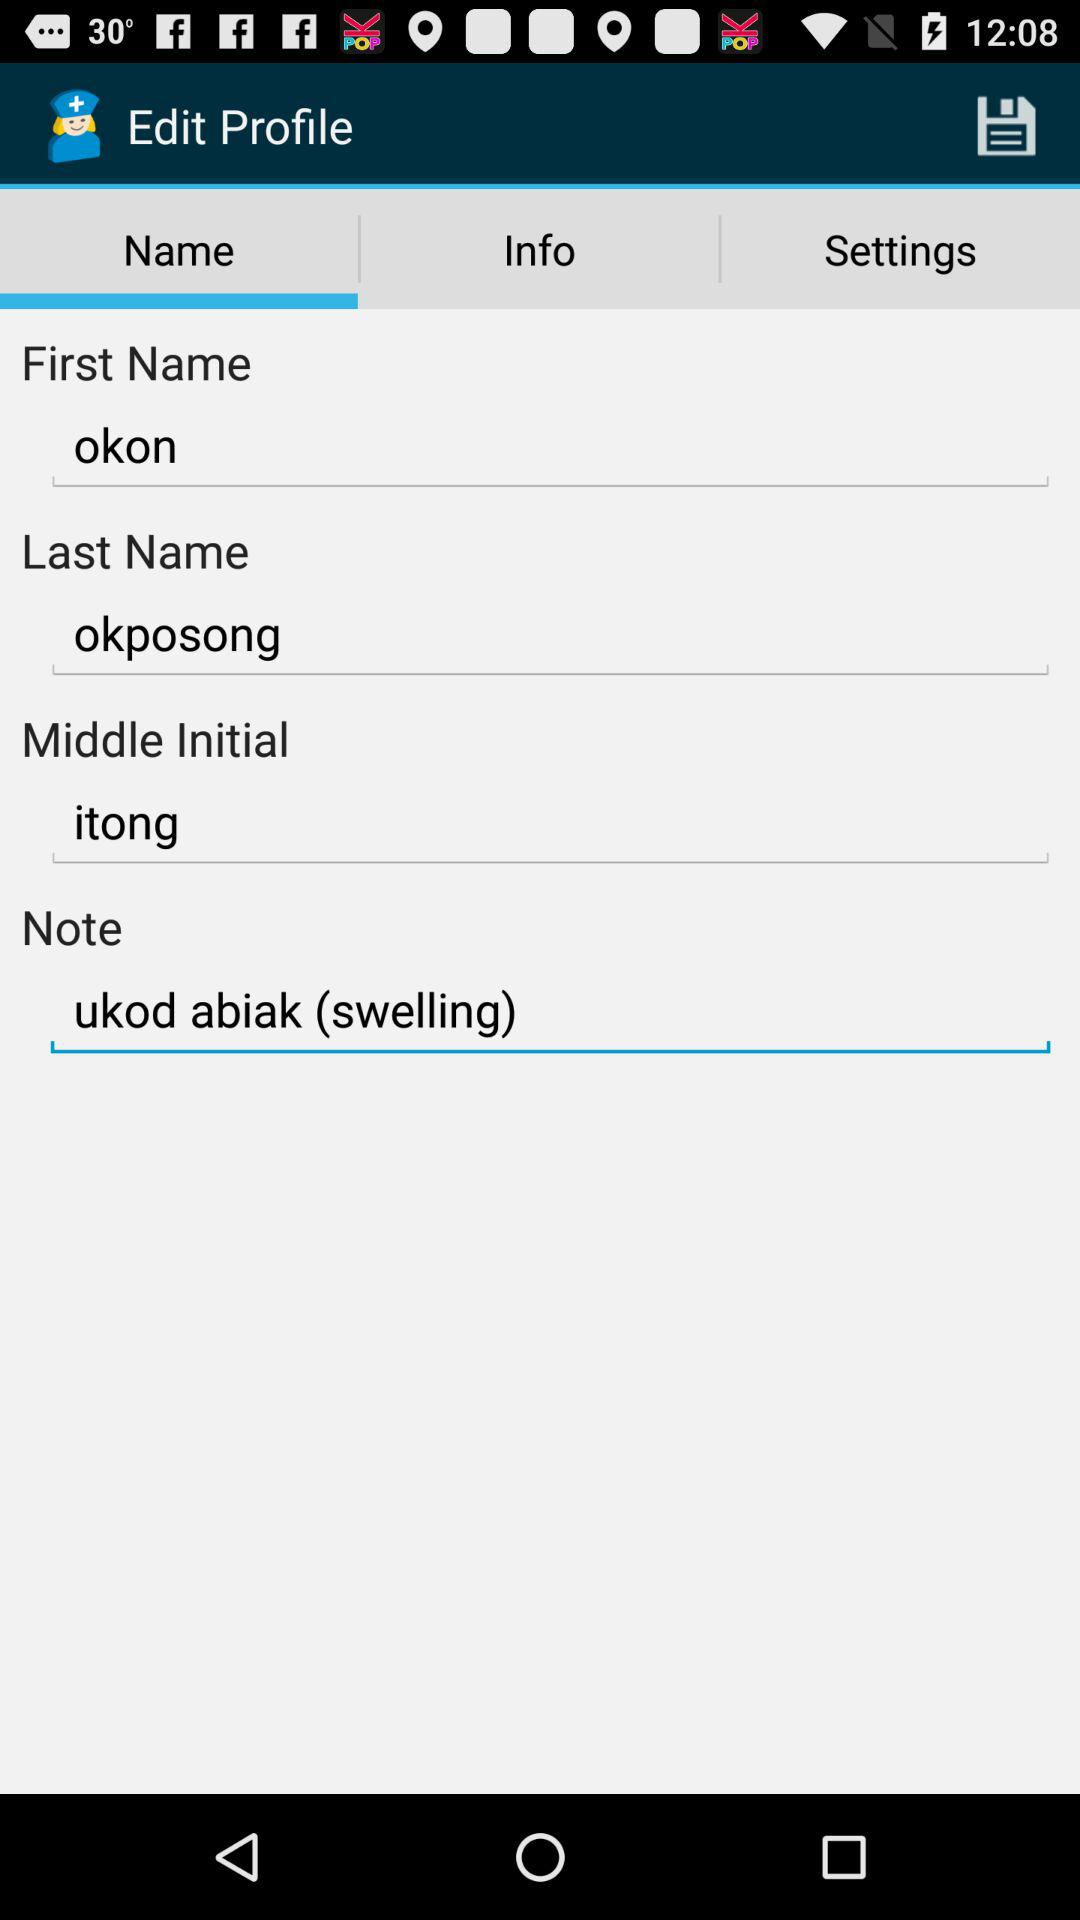Which tab are we on? You are on the "Name" tab. 